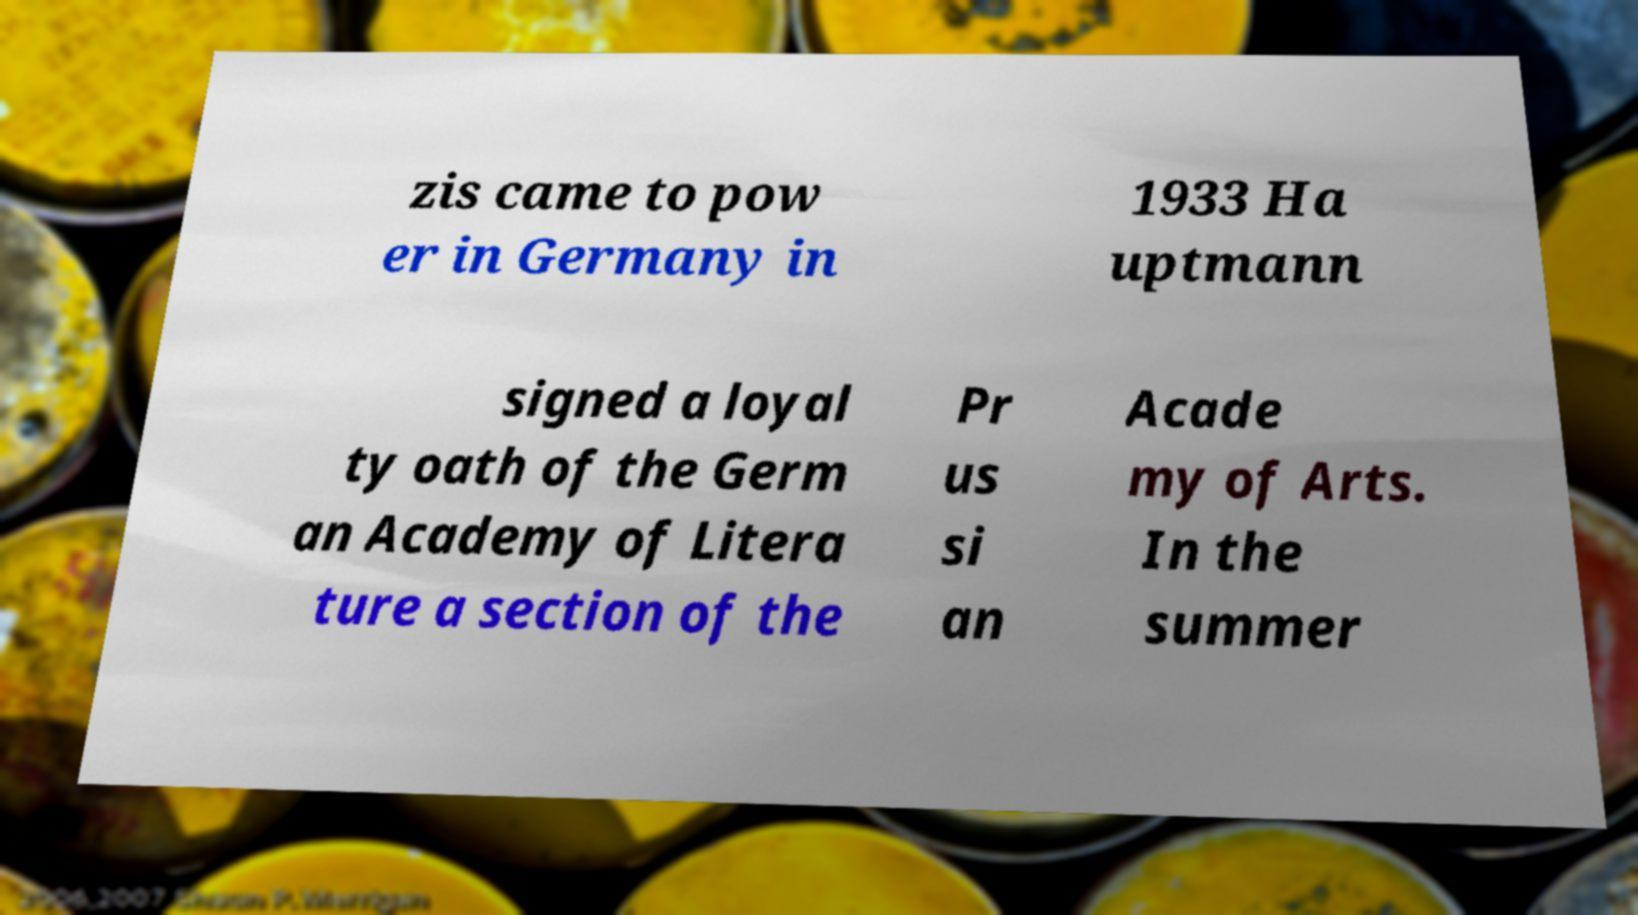What messages or text are displayed in this image? I need them in a readable, typed format. zis came to pow er in Germany in 1933 Ha uptmann signed a loyal ty oath of the Germ an Academy of Litera ture a section of the Pr us si an Acade my of Arts. In the summer 